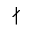<formula> <loc_0><loc_0><loc_500><loc_500>\nmid</formula> 